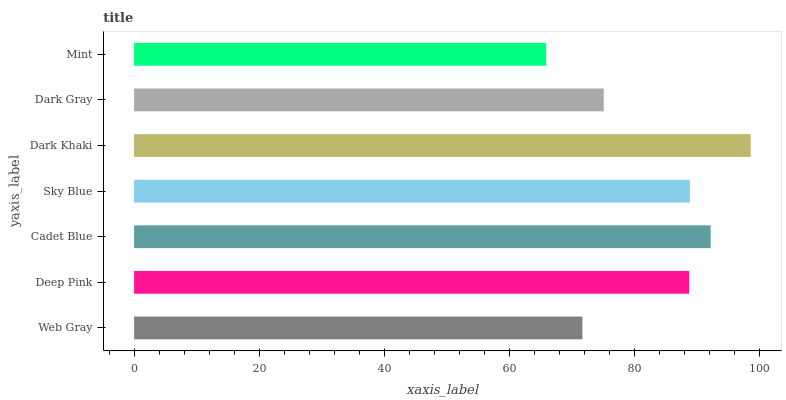Is Mint the minimum?
Answer yes or no. Yes. Is Dark Khaki the maximum?
Answer yes or no. Yes. Is Deep Pink the minimum?
Answer yes or no. No. Is Deep Pink the maximum?
Answer yes or no. No. Is Deep Pink greater than Web Gray?
Answer yes or no. Yes. Is Web Gray less than Deep Pink?
Answer yes or no. Yes. Is Web Gray greater than Deep Pink?
Answer yes or no. No. Is Deep Pink less than Web Gray?
Answer yes or no. No. Is Deep Pink the high median?
Answer yes or no. Yes. Is Deep Pink the low median?
Answer yes or no. Yes. Is Cadet Blue the high median?
Answer yes or no. No. Is Mint the low median?
Answer yes or no. No. 